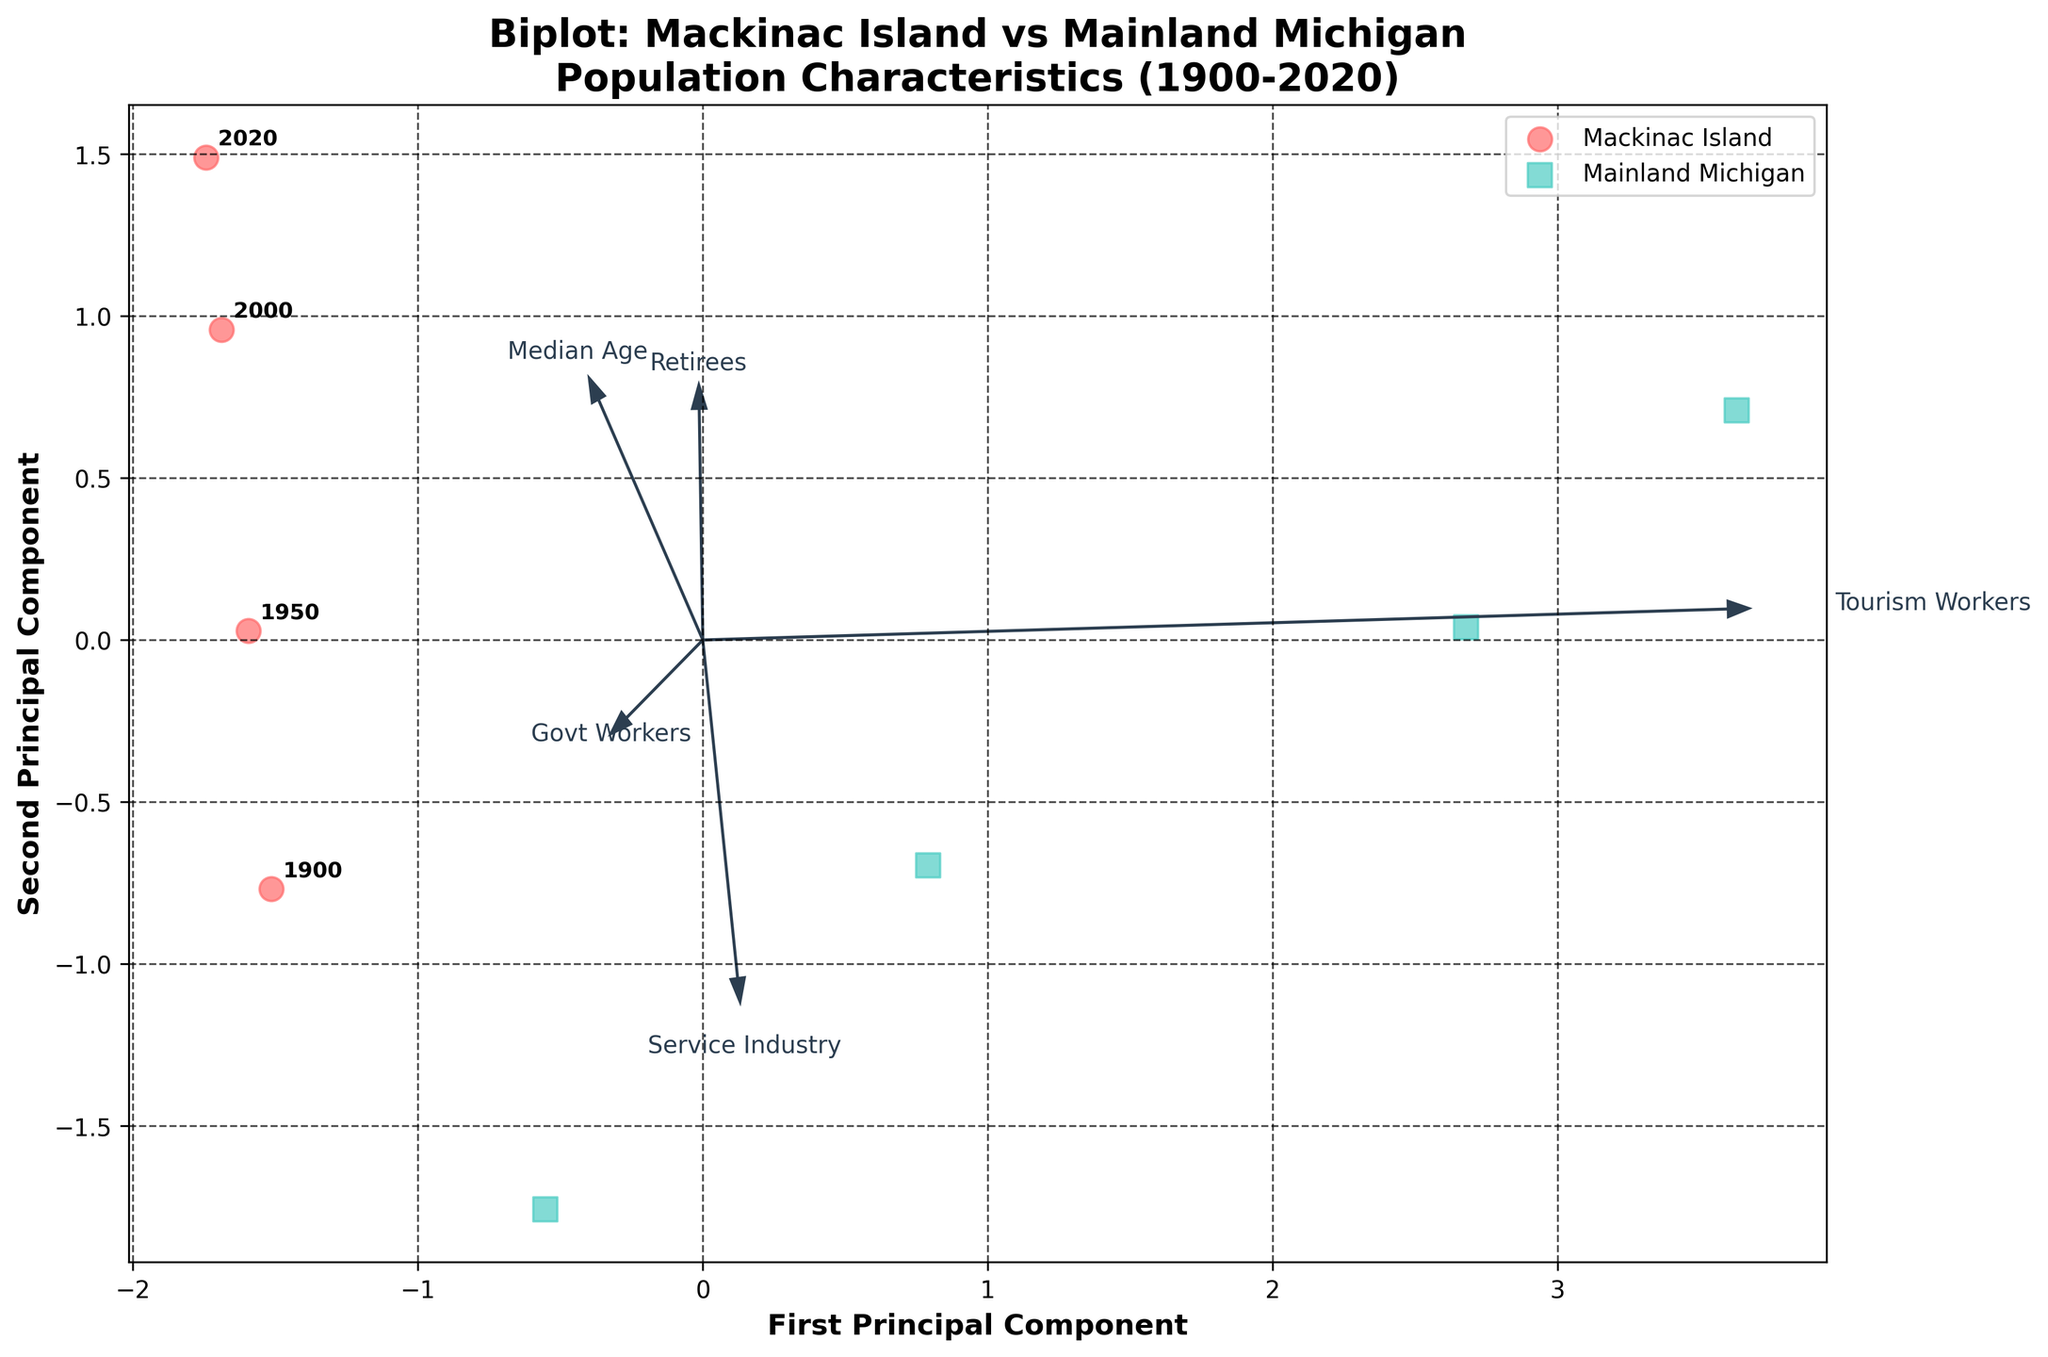What is the title of the figure? The title is displayed at the top of the figure. It reads "Biplot: Mackinac Island vs Mainland Michigan Population Characteristics (1900-2020)."
Answer: Biplot: Mackinac Island vs Mainland Michigan Population Characteristics (1900-2020) How is the first principal component labeled? The label for the first principal component can be found on the x-axis. It is labeled "First Principal Component."
Answer: First Principal Component What colors are used to represent Mackinac Island and Mainland Michigan? By looking at the legend in the figure, Mackinac Island is represented by a reddish color, while Mainland Michigan is represented by a teal color.
Answer: Reddish for Mackinac Island and teal for Mainland Michigan Which location has a higher value for Tourism Workers according to the feature vectors? The feature vector for Tourism Workers extends further towards Mainland Michigan in the biplot. Thus, Mainland Michigan has a higher value for Tourism Workers.
Answer: Mainland Michigan How does the direction of the 'Median Age' vector compare to 'Retirees'? Both the 'Median Age' and 'Retirees' vectors are pointing in the general same direction in the biplot. This indicates a correlation between the two features.
Answer: Same direction Which principal component is more aligned with the 'Service Industry' vector? By examining the direction of the 'Service Industry' vector, it aligns more closely with the first principal component, as its arrow extends more horizontally than vertically.
Answer: First Principal Component Comparing Mackinac Island and Mainland Michigan, which location has a greater variability in age and occupation characteristics? Mainland Michigan points are more spread out in the biplot in both principal components compared to Mackinac Island, indicating greater variability.
Answer: Mainland Michigan In the year 2000, which location shows higher values in both principal components? Observing the annotated point for the year 2000, Mainland Michigan is positioned further along both the first and second principal components compared to Mackinac Island.
Answer: Mainland Michigan Is there any noticeable trend in the median age of Mackinac Island from 1900 to 2020? The 'Median Age' vector shows a consistent direction over time in Mackinac Island, indicating an increase in the median age. Each later year is closer to the 'Median Age' vector direction.
Answer: Increasing trend Between 'Govt Workers' and 'Service Industry', which feature contributes more significantly to the second principal component? The length of the 'Govt Workers' vector along the y-axis is longer than that of 'Service Industry', suggesting it contributes more significantly to the second principal component.
Answer: Govt Workers 